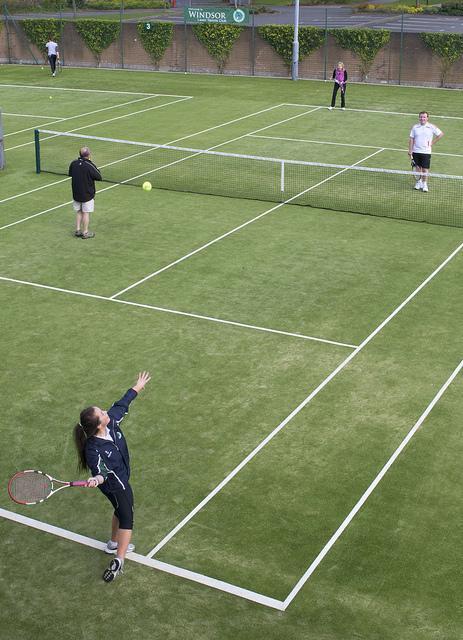How many balls are on the ground?
Give a very brief answer. 0. How many hospital beds are there?
Give a very brief answer. 0. 